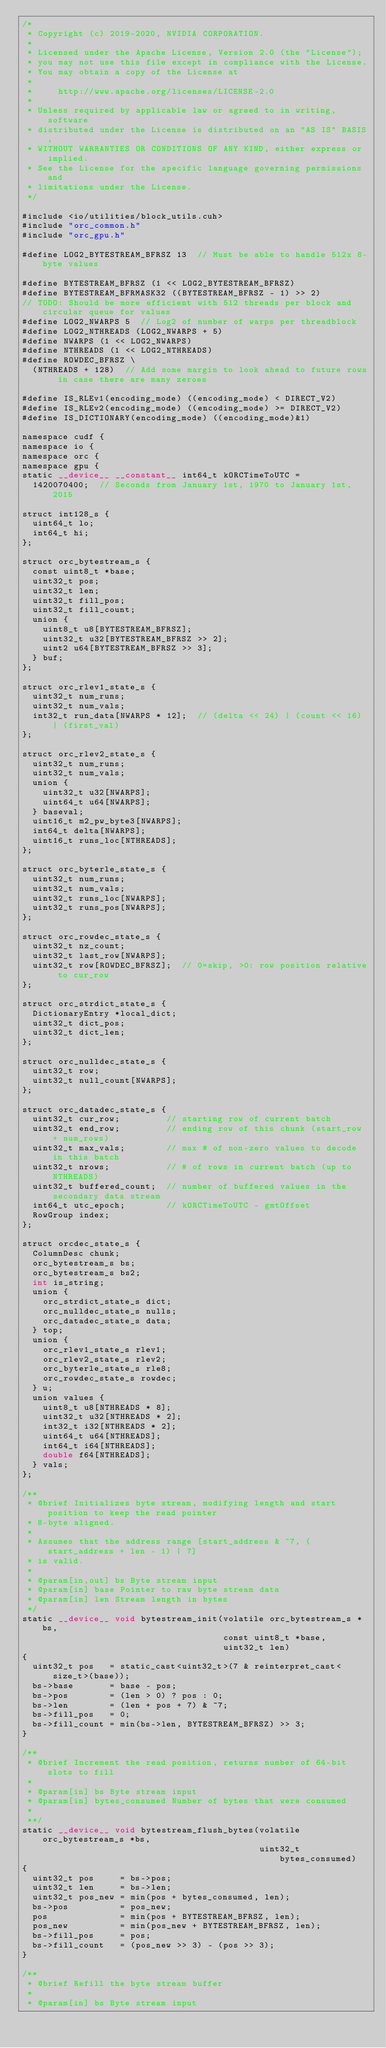Convert code to text. <code><loc_0><loc_0><loc_500><loc_500><_Cuda_>/*
 * Copyright (c) 2019-2020, NVIDIA CORPORATION.
 *
 * Licensed under the Apache License, Version 2.0 (the "License");
 * you may not use this file except in compliance with the License.
 * You may obtain a copy of the License at
 *
 *     http://www.apache.org/licenses/LICENSE-2.0
 *
 * Unless required by applicable law or agreed to in writing, software
 * distributed under the License is distributed on an "AS IS" BASIS,
 * WITHOUT WARRANTIES OR CONDITIONS OF ANY KIND, either express or implied.
 * See the License for the specific language governing permissions and
 * limitations under the License.
 */

#include <io/utilities/block_utils.cuh>
#include "orc_common.h"
#include "orc_gpu.h"

#define LOG2_BYTESTREAM_BFRSZ 13  // Must be able to handle 512x 8-byte values

#define BYTESTREAM_BFRSZ (1 << LOG2_BYTESTREAM_BFRSZ)
#define BYTESTREAM_BFRMASK32 ((BYTESTREAM_BFRSZ - 1) >> 2)
// TODO: Should be more efficient with 512 threads per block and circular queue for values
#define LOG2_NWARPS 5  // Log2 of number of warps per threadblock
#define LOG2_NTHREADS (LOG2_NWARPS + 5)
#define NWARPS (1 << LOG2_NWARPS)
#define NTHREADS (1 << LOG2_NTHREADS)
#define ROWDEC_BFRSZ \
  (NTHREADS + 128)  // Add some margin to look ahead to future rows in case there are many zeroes

#define IS_RLEv1(encoding_mode) ((encoding_mode) < DIRECT_V2)
#define IS_RLEv2(encoding_mode) ((encoding_mode) >= DIRECT_V2)
#define IS_DICTIONARY(encoding_mode) ((encoding_mode)&1)

namespace cudf {
namespace io {
namespace orc {
namespace gpu {
static __device__ __constant__ int64_t kORCTimeToUTC =
  1420070400;  // Seconds from January 1st, 1970 to January 1st, 2015

struct int128_s {
  uint64_t lo;
  int64_t hi;
};

struct orc_bytestream_s {
  const uint8_t *base;
  uint32_t pos;
  uint32_t len;
  uint32_t fill_pos;
  uint32_t fill_count;
  union {
    uint8_t u8[BYTESTREAM_BFRSZ];
    uint32_t u32[BYTESTREAM_BFRSZ >> 2];
    uint2 u64[BYTESTREAM_BFRSZ >> 3];
  } buf;
};

struct orc_rlev1_state_s {
  uint32_t num_runs;
  uint32_t num_vals;
  int32_t run_data[NWARPS * 12];  // (delta << 24) | (count << 16) | (first_val)
};

struct orc_rlev2_state_s {
  uint32_t num_runs;
  uint32_t num_vals;
  union {
    uint32_t u32[NWARPS];
    uint64_t u64[NWARPS];
  } baseval;
  uint16_t m2_pw_byte3[NWARPS];
  int64_t delta[NWARPS];
  uint16_t runs_loc[NTHREADS];
};

struct orc_byterle_state_s {
  uint32_t num_runs;
  uint32_t num_vals;
  uint32_t runs_loc[NWARPS];
  uint32_t runs_pos[NWARPS];
};

struct orc_rowdec_state_s {
  uint32_t nz_count;
  uint32_t last_row[NWARPS];
  uint32_t row[ROWDEC_BFRSZ];  // 0=skip, >0: row position relative to cur_row
};

struct orc_strdict_state_s {
  DictionaryEntry *local_dict;
  uint32_t dict_pos;
  uint32_t dict_len;
};

struct orc_nulldec_state_s {
  uint32_t row;
  uint32_t null_count[NWARPS];
};

struct orc_datadec_state_s {
  uint32_t cur_row;         // starting row of current batch
  uint32_t end_row;         // ending row of this chunk (start_row + num_rows)
  uint32_t max_vals;        // max # of non-zero values to decode in this batch
  uint32_t nrows;           // # of rows in current batch (up to NTHREADS)
  uint32_t buffered_count;  // number of buffered values in the secondary data stream
  int64_t utc_epoch;        // kORCTimeToUTC - gmtOffset
  RowGroup index;
};

struct orcdec_state_s {
  ColumnDesc chunk;
  orc_bytestream_s bs;
  orc_bytestream_s bs2;
  int is_string;
  union {
    orc_strdict_state_s dict;
    orc_nulldec_state_s nulls;
    orc_datadec_state_s data;
  } top;
  union {
    orc_rlev1_state_s rlev1;
    orc_rlev2_state_s rlev2;
    orc_byterle_state_s rle8;
    orc_rowdec_state_s rowdec;
  } u;
  union values {
    uint8_t u8[NTHREADS * 8];
    uint32_t u32[NTHREADS * 2];
    int32_t i32[NTHREADS * 2];
    uint64_t u64[NTHREADS];
    int64_t i64[NTHREADS];
    double f64[NTHREADS];
  } vals;
};

/**
 * @brief Initializes byte stream, modifying length and start position to keep the read pointer
 * 8-byte aligned.
 *
 * Assumes that the address range [start_address & ~7, (start_address + len - 1) | 7]
 * is valid.
 *
 * @param[in,out] bs Byte stream input
 * @param[in] base Pointer to raw byte stream data
 * @param[in] len Stream length in bytes
 */
static __device__ void bytestream_init(volatile orc_bytestream_s *bs,
                                       const uint8_t *base,
                                       uint32_t len)
{
  uint32_t pos   = static_cast<uint32_t>(7 & reinterpret_cast<size_t>(base));
  bs->base       = base - pos;
  bs->pos        = (len > 0) ? pos : 0;
  bs->len        = (len + pos + 7) & ~7;
  bs->fill_pos   = 0;
  bs->fill_count = min(bs->len, BYTESTREAM_BFRSZ) >> 3;
}

/**
 * @brief Increment the read position, returns number of 64-bit slots to fill
 *
 * @param[in] bs Byte stream input
 * @param[in] bytes_consumed Number of bytes that were consumed
 *
 **/
static __device__ void bytestream_flush_bytes(volatile orc_bytestream_s *bs,
                                              uint32_t bytes_consumed)
{
  uint32_t pos     = bs->pos;
  uint32_t len     = bs->len;
  uint32_t pos_new = min(pos + bytes_consumed, len);
  bs->pos          = pos_new;
  pos              = min(pos + BYTESTREAM_BFRSZ, len);
  pos_new          = min(pos_new + BYTESTREAM_BFRSZ, len);
  bs->fill_pos     = pos;
  bs->fill_count   = (pos_new >> 3) - (pos >> 3);
}

/**
 * @brief Refill the byte stream buffer
 *
 * @param[in] bs Byte stream input</code> 